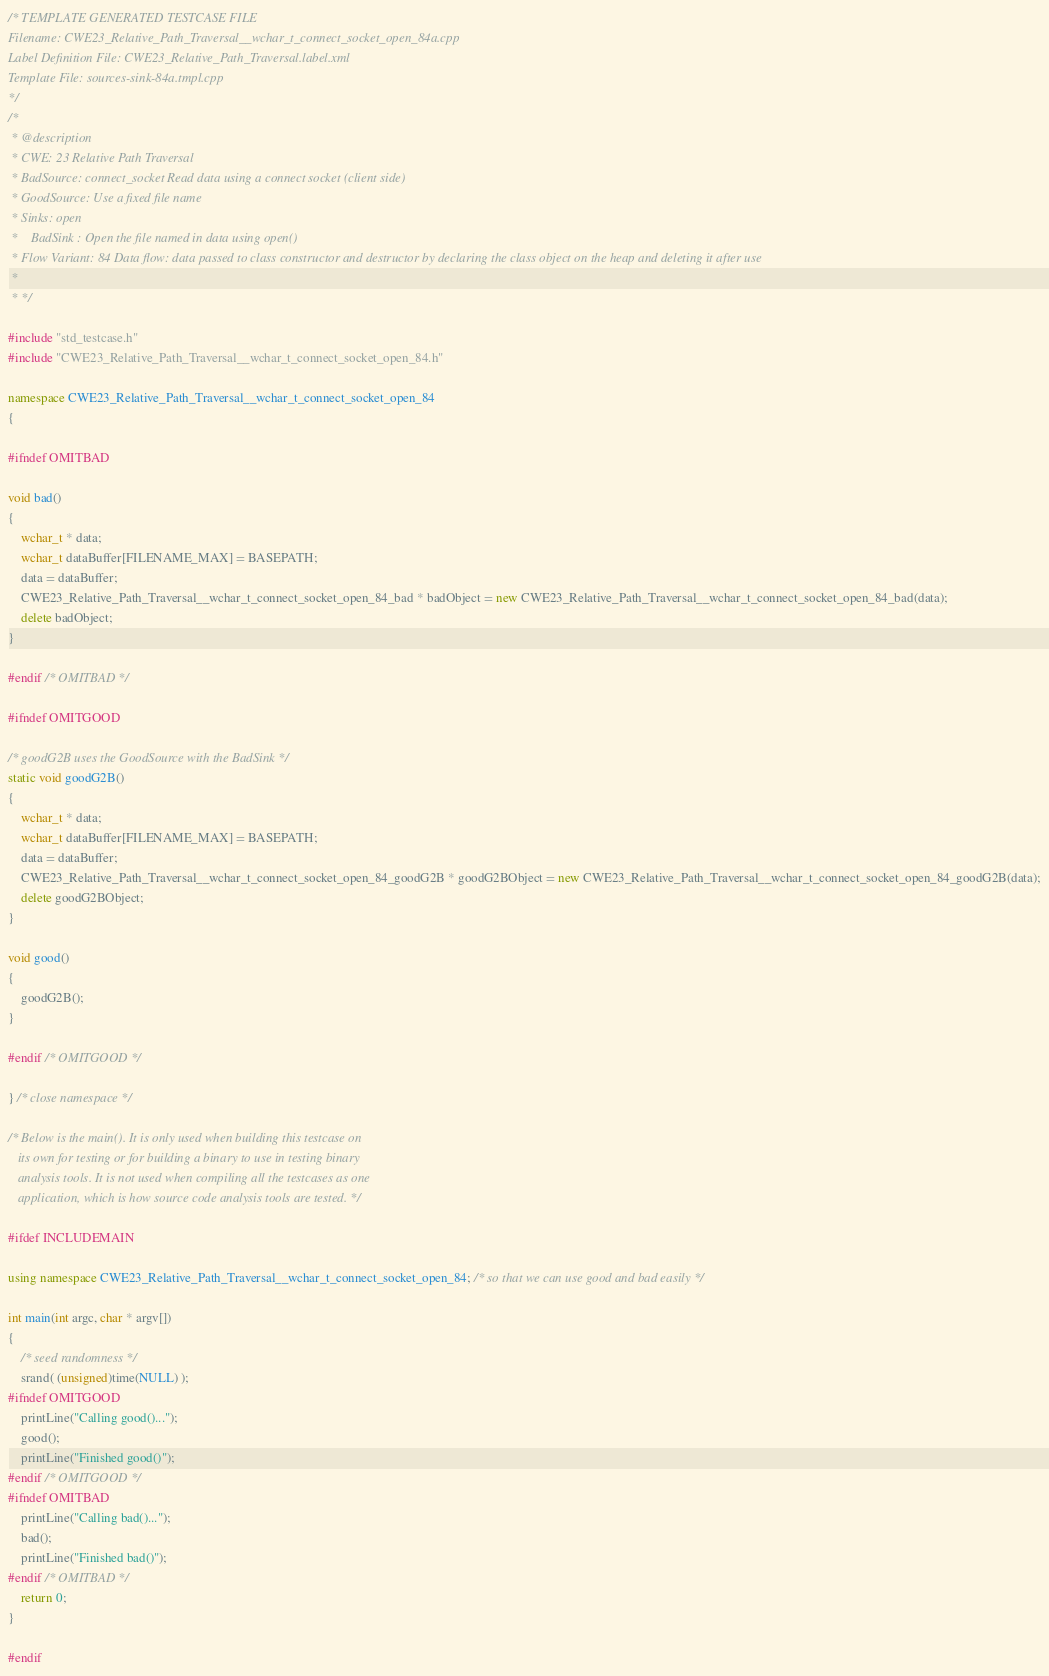Convert code to text. <code><loc_0><loc_0><loc_500><loc_500><_C++_>/* TEMPLATE GENERATED TESTCASE FILE
Filename: CWE23_Relative_Path_Traversal__wchar_t_connect_socket_open_84a.cpp
Label Definition File: CWE23_Relative_Path_Traversal.label.xml
Template File: sources-sink-84a.tmpl.cpp
*/
/*
 * @description
 * CWE: 23 Relative Path Traversal
 * BadSource: connect_socket Read data using a connect socket (client side)
 * GoodSource: Use a fixed file name
 * Sinks: open
 *    BadSink : Open the file named in data using open()
 * Flow Variant: 84 Data flow: data passed to class constructor and destructor by declaring the class object on the heap and deleting it after use
 *
 * */

#include "std_testcase.h"
#include "CWE23_Relative_Path_Traversal__wchar_t_connect_socket_open_84.h"

namespace CWE23_Relative_Path_Traversal__wchar_t_connect_socket_open_84
{

#ifndef OMITBAD

void bad()
{
    wchar_t * data;
    wchar_t dataBuffer[FILENAME_MAX] = BASEPATH;
    data = dataBuffer;
    CWE23_Relative_Path_Traversal__wchar_t_connect_socket_open_84_bad * badObject = new CWE23_Relative_Path_Traversal__wchar_t_connect_socket_open_84_bad(data);
    delete badObject;
}

#endif /* OMITBAD */

#ifndef OMITGOOD

/* goodG2B uses the GoodSource with the BadSink */
static void goodG2B()
{
    wchar_t * data;
    wchar_t dataBuffer[FILENAME_MAX] = BASEPATH;
    data = dataBuffer;
    CWE23_Relative_Path_Traversal__wchar_t_connect_socket_open_84_goodG2B * goodG2BObject = new CWE23_Relative_Path_Traversal__wchar_t_connect_socket_open_84_goodG2B(data);
    delete goodG2BObject;
}

void good()
{
    goodG2B();
}

#endif /* OMITGOOD */

} /* close namespace */

/* Below is the main(). It is only used when building this testcase on
   its own for testing or for building a binary to use in testing binary
   analysis tools. It is not used when compiling all the testcases as one
   application, which is how source code analysis tools are tested. */

#ifdef INCLUDEMAIN

using namespace CWE23_Relative_Path_Traversal__wchar_t_connect_socket_open_84; /* so that we can use good and bad easily */

int main(int argc, char * argv[])
{
    /* seed randomness */
    srand( (unsigned)time(NULL) );
#ifndef OMITGOOD
    printLine("Calling good()...");
    good();
    printLine("Finished good()");
#endif /* OMITGOOD */
#ifndef OMITBAD
    printLine("Calling bad()...");
    bad();
    printLine("Finished bad()");
#endif /* OMITBAD */
    return 0;
}

#endif
</code> 